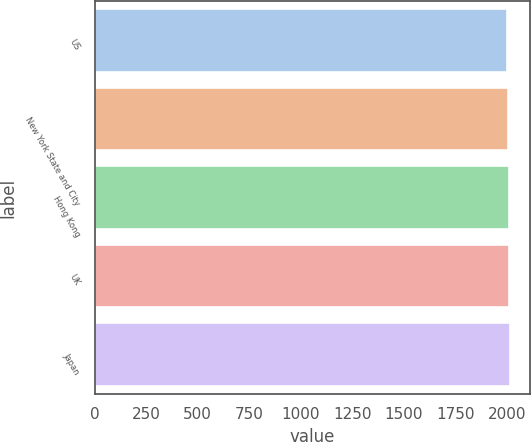<chart> <loc_0><loc_0><loc_500><loc_500><bar_chart><fcel>US<fcel>New York State and City<fcel>Hong Kong<fcel>UK<fcel>Japan<nl><fcel>1999<fcel>2007<fcel>2008.3<fcel>2010<fcel>2012<nl></chart> 